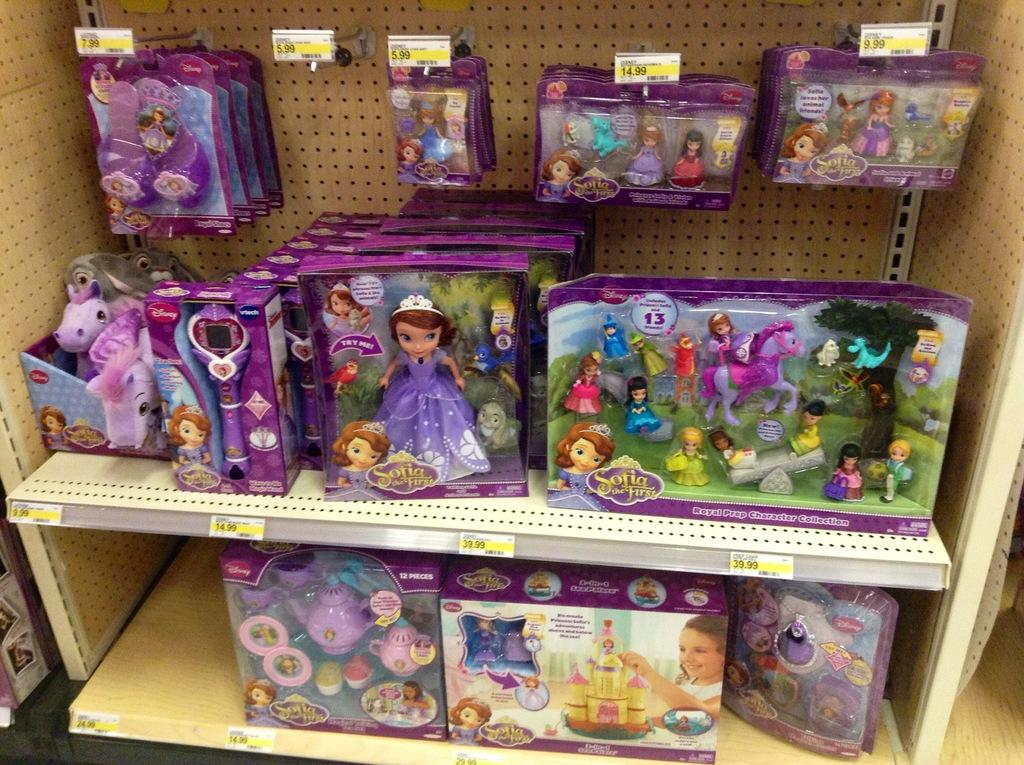What type of objects can be seen in the image? There are many toys in the image. How are the toys arranged or displayed in the image? The toys are placed on or hanged from wood. What type of juice is being served by the servant in the image? There is no servant or juice present in the image; it only features toys placed on or hanged from wood. 